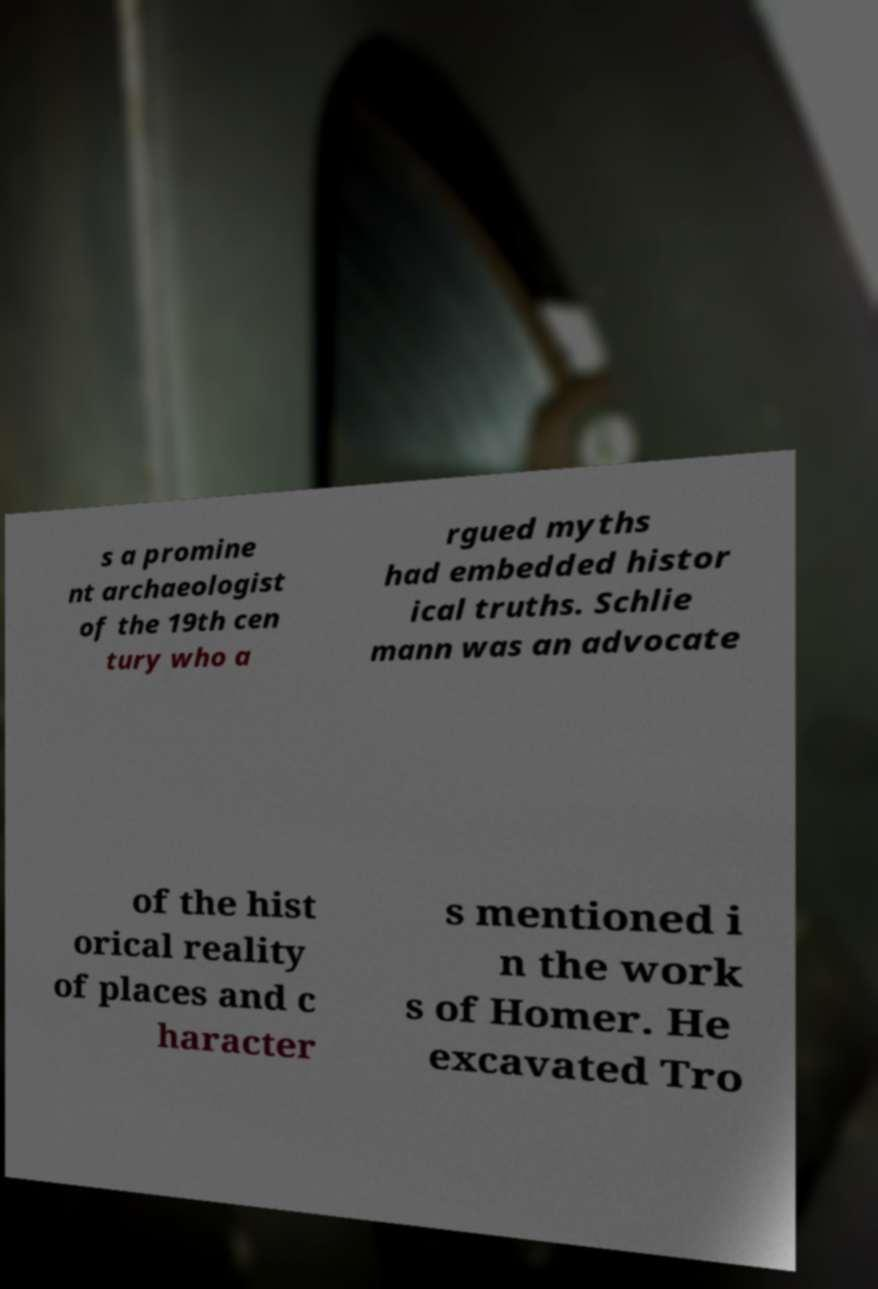For documentation purposes, I need the text within this image transcribed. Could you provide that? s a promine nt archaeologist of the 19th cen tury who a rgued myths had embedded histor ical truths. Schlie mann was an advocate of the hist orical reality of places and c haracter s mentioned i n the work s of Homer. He excavated Tro 